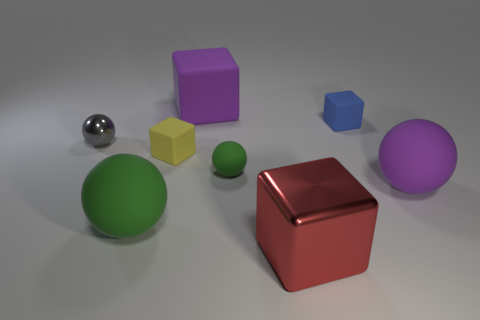Subtract all red cubes. How many cubes are left? 3 Add 1 small objects. How many objects exist? 9 Subtract all brown balls. Subtract all blue cylinders. How many balls are left? 4 Add 5 big matte blocks. How many big matte blocks are left? 6 Add 7 small cyan rubber cubes. How many small cyan rubber cubes exist? 7 Subtract 1 yellow cubes. How many objects are left? 7 Subtract all small red rubber balls. Subtract all blue things. How many objects are left? 7 